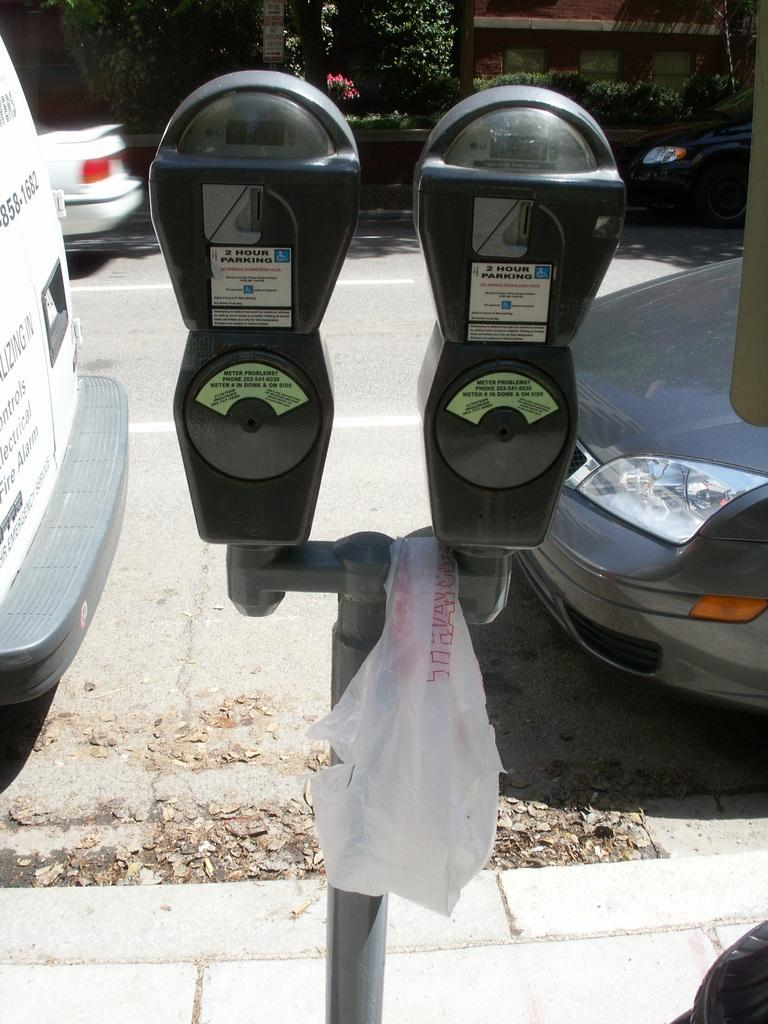Provide a one-sentence caption for the provided image. Two cars are parked beside two meters with timers. 